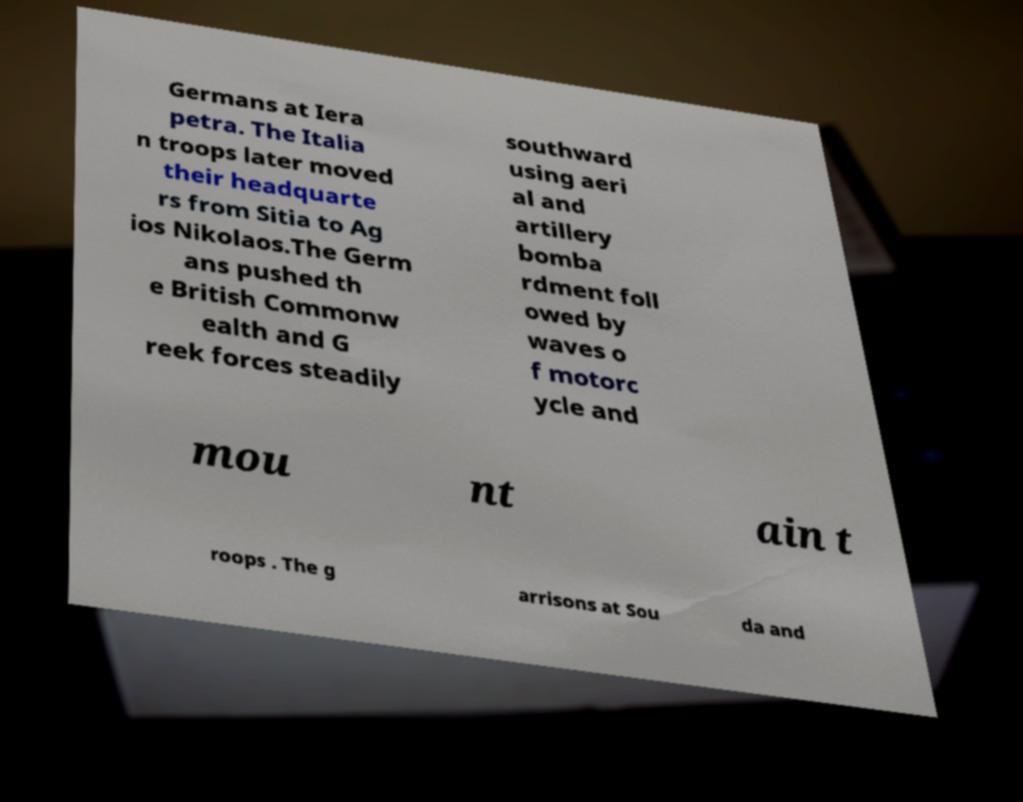For documentation purposes, I need the text within this image transcribed. Could you provide that? Germans at Iera petra. The Italia n troops later moved their headquarte rs from Sitia to Ag ios Nikolaos.The Germ ans pushed th e British Commonw ealth and G reek forces steadily southward using aeri al and artillery bomba rdment foll owed by waves o f motorc ycle and mou nt ain t roops . The g arrisons at Sou da and 